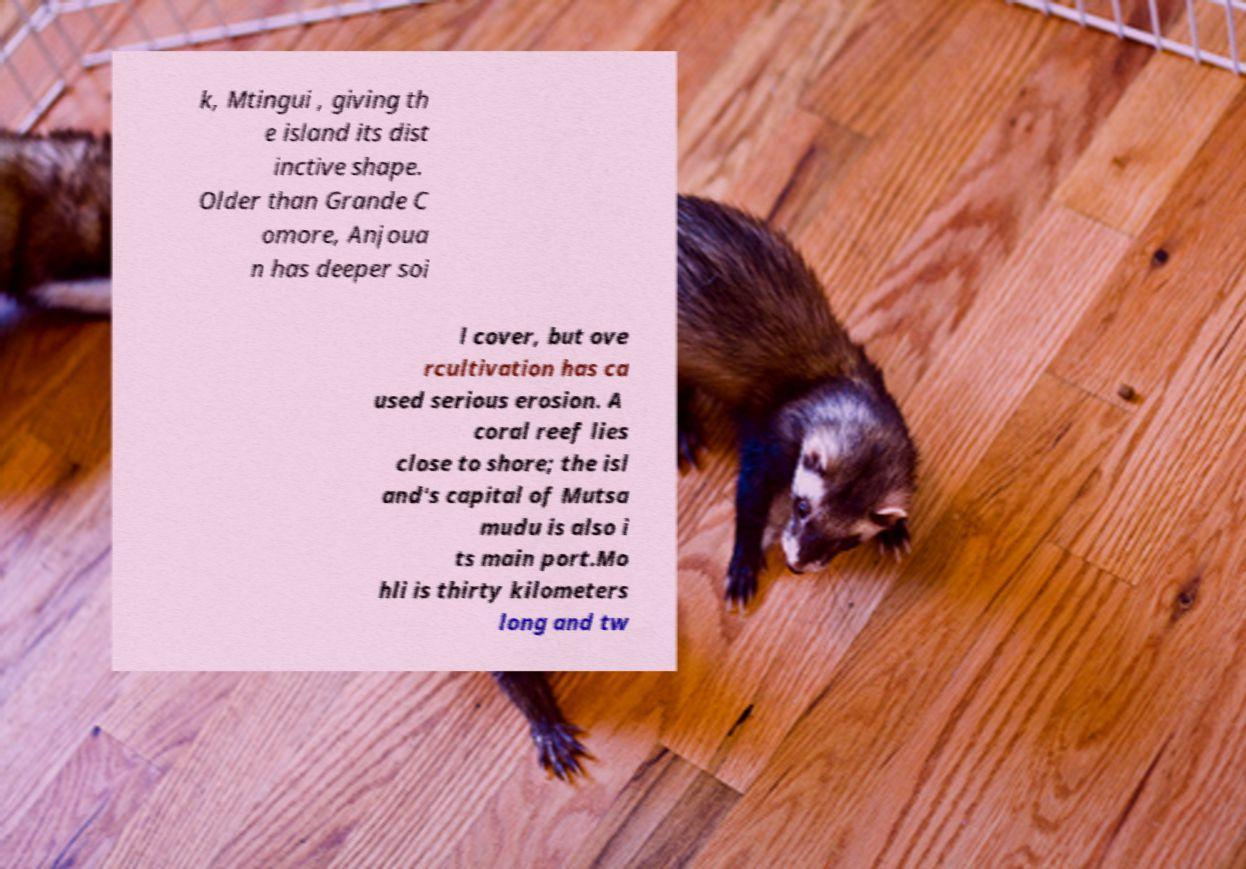Can you accurately transcribe the text from the provided image for me? k, Mtingui , giving th e island its dist inctive shape. Older than Grande C omore, Anjoua n has deeper soi l cover, but ove rcultivation has ca used serious erosion. A coral reef lies close to shore; the isl and's capital of Mutsa mudu is also i ts main port.Mo hli is thirty kilometers long and tw 